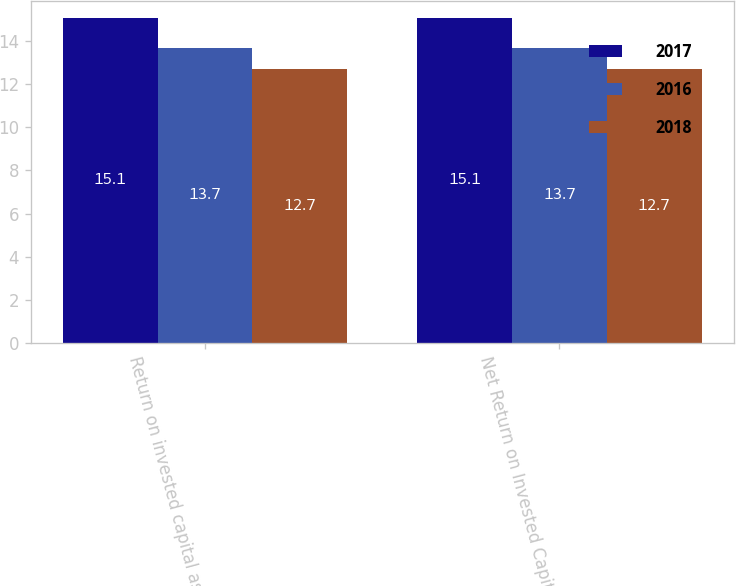Convert chart. <chart><loc_0><loc_0><loc_500><loc_500><stacked_bar_chart><ecel><fcel>Return on invested capital as<fcel>Net Return on Invested Capital<nl><fcel>2017<fcel>15.1<fcel>15.1<nl><fcel>2016<fcel>13.7<fcel>13.7<nl><fcel>2018<fcel>12.7<fcel>12.7<nl></chart> 